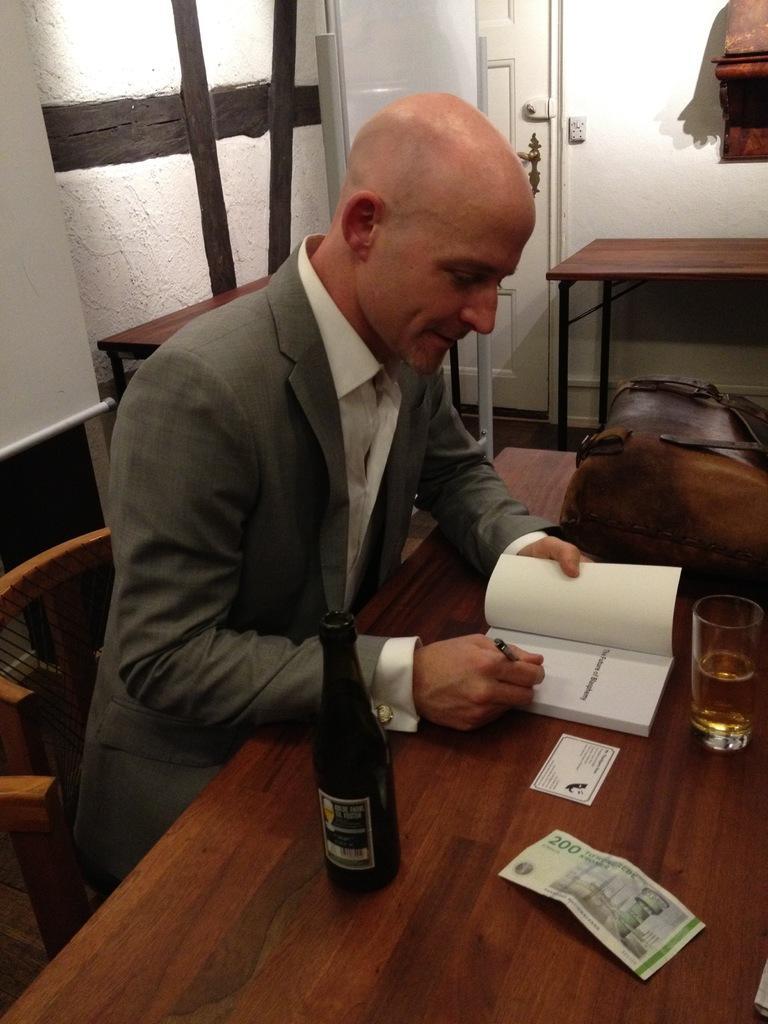Please provide a concise description of this image. The image is inside the room. In the image we can see a man holding a pen and writing on his book. The book is placed on the table on table we can see a bottle,money,card,glass with some drink,bag. In background we can see a white color wall and white color door which is closed. 